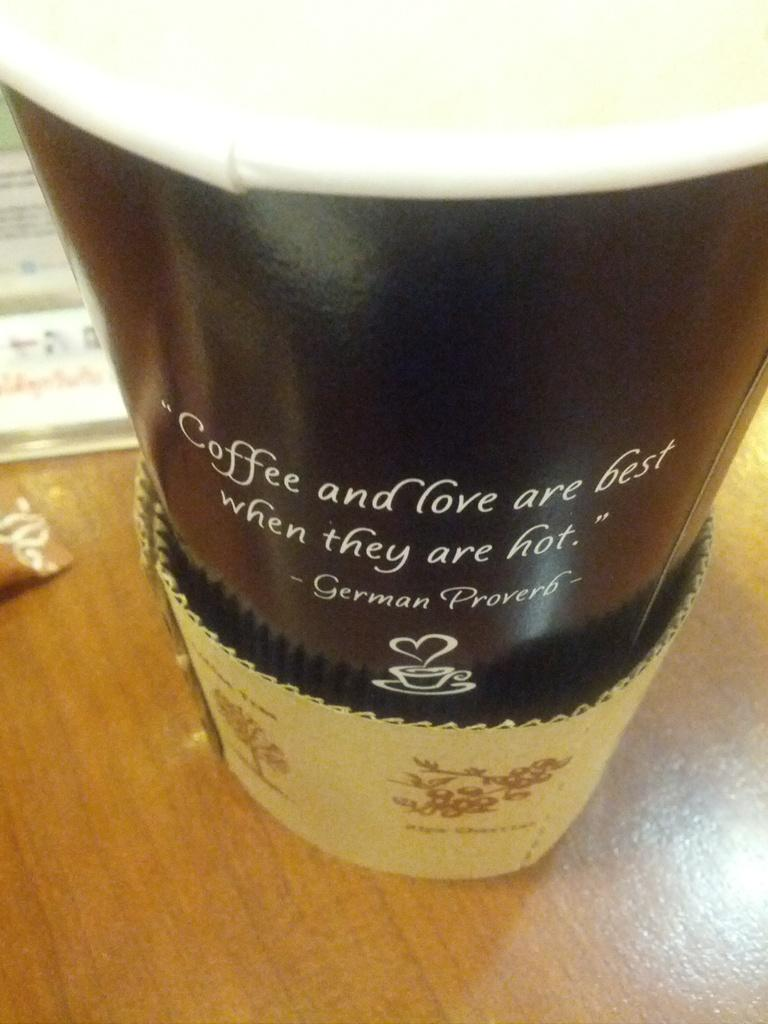<image>
Offer a succinct explanation of the picture presented. A coffee cup with a quote from a German Proverb on it 